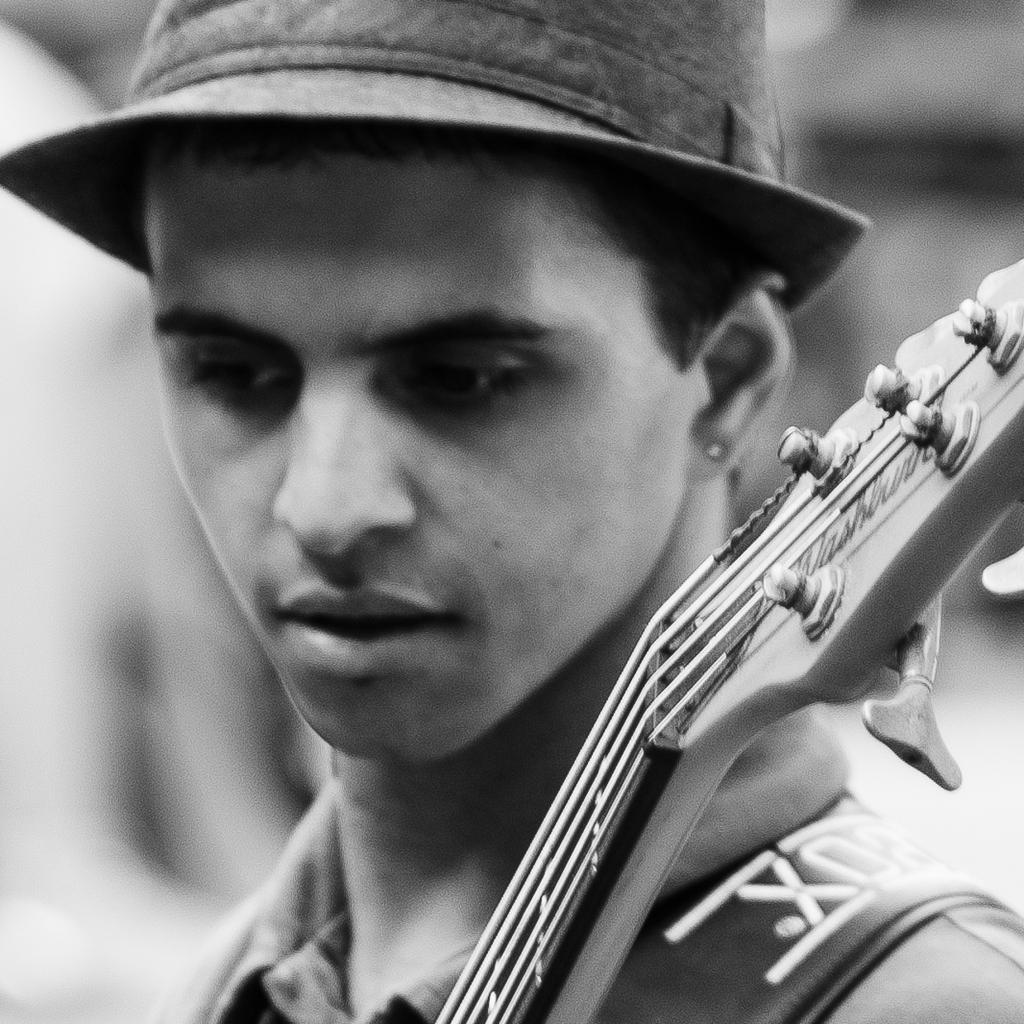What can be seen in the image? There is a person and a musical instrument in the image. Can you describe the person in the image? Unfortunately, the provided facts do not give any details about the person's appearance or actions. What type of musical instrument is present in the image? The facts do not specify the type of musical instrument. What is the background of the image like? The background of the image is blurry. What type of drink is the person holding in the image? There is no drink visible in the image. Can you describe the horn that is being played by the person in the image? There is no horn present in the image, and the type of musical instrument is not specified. What is the person using the pail for in the image? There is no pail present in the image. 